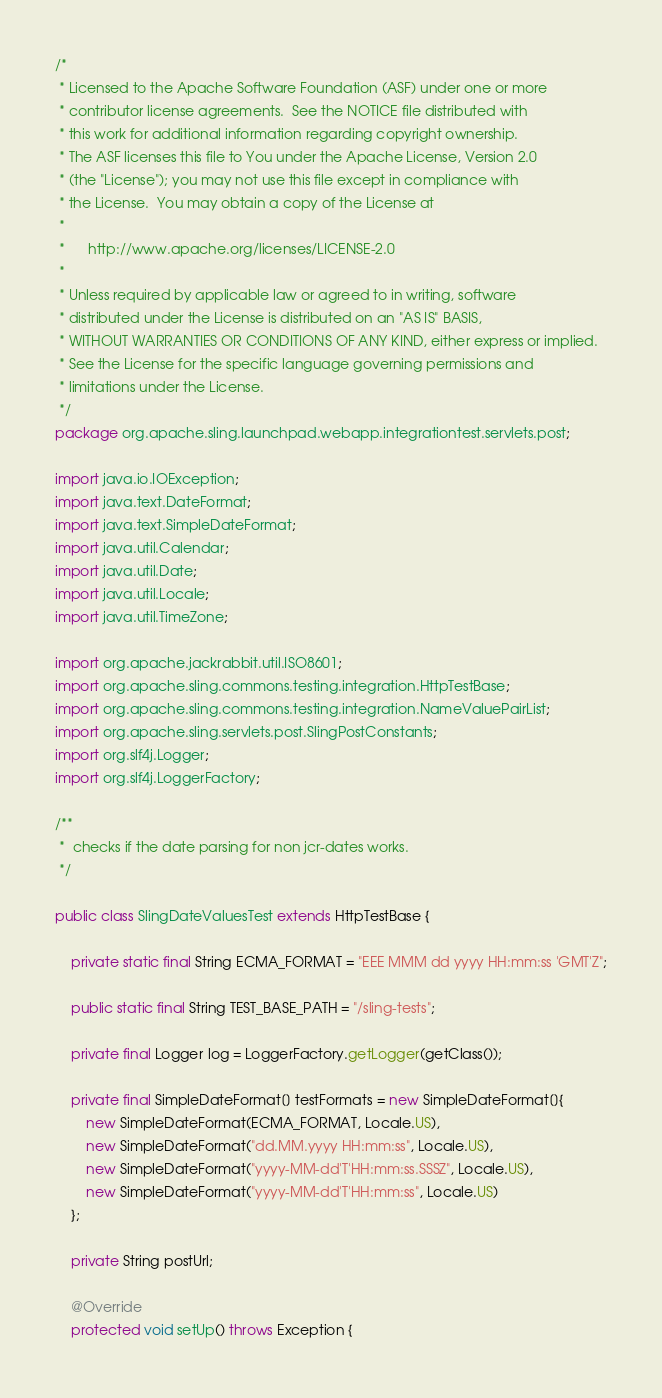<code> <loc_0><loc_0><loc_500><loc_500><_Java_>/*
 * Licensed to the Apache Software Foundation (ASF) under one or more
 * contributor license agreements.  See the NOTICE file distributed with
 * this work for additional information regarding copyright ownership.
 * The ASF licenses this file to You under the Apache License, Version 2.0
 * (the "License"); you may not use this file except in compliance with
 * the License.  You may obtain a copy of the License at
 *
 *      http://www.apache.org/licenses/LICENSE-2.0
 *
 * Unless required by applicable law or agreed to in writing, software
 * distributed under the License is distributed on an "AS IS" BASIS,
 * WITHOUT WARRANTIES OR CONDITIONS OF ANY KIND, either express or implied.
 * See the License for the specific language governing permissions and
 * limitations under the License.
 */
package org.apache.sling.launchpad.webapp.integrationtest.servlets.post;

import java.io.IOException;
import java.text.DateFormat;
import java.text.SimpleDateFormat;
import java.util.Calendar;
import java.util.Date;
import java.util.Locale;
import java.util.TimeZone;

import org.apache.jackrabbit.util.ISO8601;
import org.apache.sling.commons.testing.integration.HttpTestBase;
import org.apache.sling.commons.testing.integration.NameValuePairList;
import org.apache.sling.servlets.post.SlingPostConstants;
import org.slf4j.Logger;
import org.slf4j.LoggerFactory;

/**
 *  checks if the date parsing for non jcr-dates works.
 */

public class SlingDateValuesTest extends HttpTestBase {

    private static final String ECMA_FORMAT = "EEE MMM dd yyyy HH:mm:ss 'GMT'Z";

    public static final String TEST_BASE_PATH = "/sling-tests";
    
    private final Logger log = LoggerFactory.getLogger(getClass());

    private final SimpleDateFormat[] testFormats = new SimpleDateFormat[]{
        new SimpleDateFormat(ECMA_FORMAT, Locale.US),
        new SimpleDateFormat("dd.MM.yyyy HH:mm:ss", Locale.US),
        new SimpleDateFormat("yyyy-MM-dd'T'HH:mm:ss.SSSZ", Locale.US),
        new SimpleDateFormat("yyyy-MM-dd'T'HH:mm:ss", Locale.US)
    };

    private String postUrl;

    @Override
    protected void setUp() throws Exception {</code> 